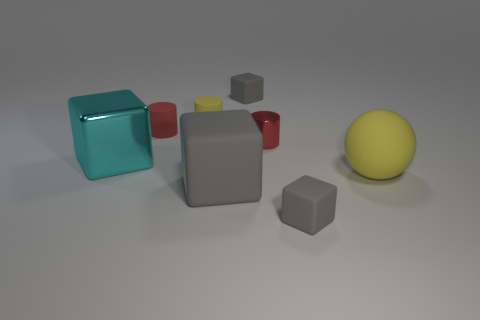Subtract all gray blocks. How many were subtracted if there are1gray blocks left? 2 Subtract all cyan blocks. How many blocks are left? 3 Subtract all red matte cylinders. How many cylinders are left? 2 Subtract all yellow cubes. How many red cylinders are left? 2 Subtract all matte balls. Subtract all large yellow objects. How many objects are left? 6 Add 6 tiny yellow matte cylinders. How many tiny yellow matte cylinders are left? 7 Add 3 blocks. How many blocks exist? 7 Add 2 cylinders. How many objects exist? 10 Subtract 0 cyan cylinders. How many objects are left? 8 Subtract all spheres. How many objects are left? 7 